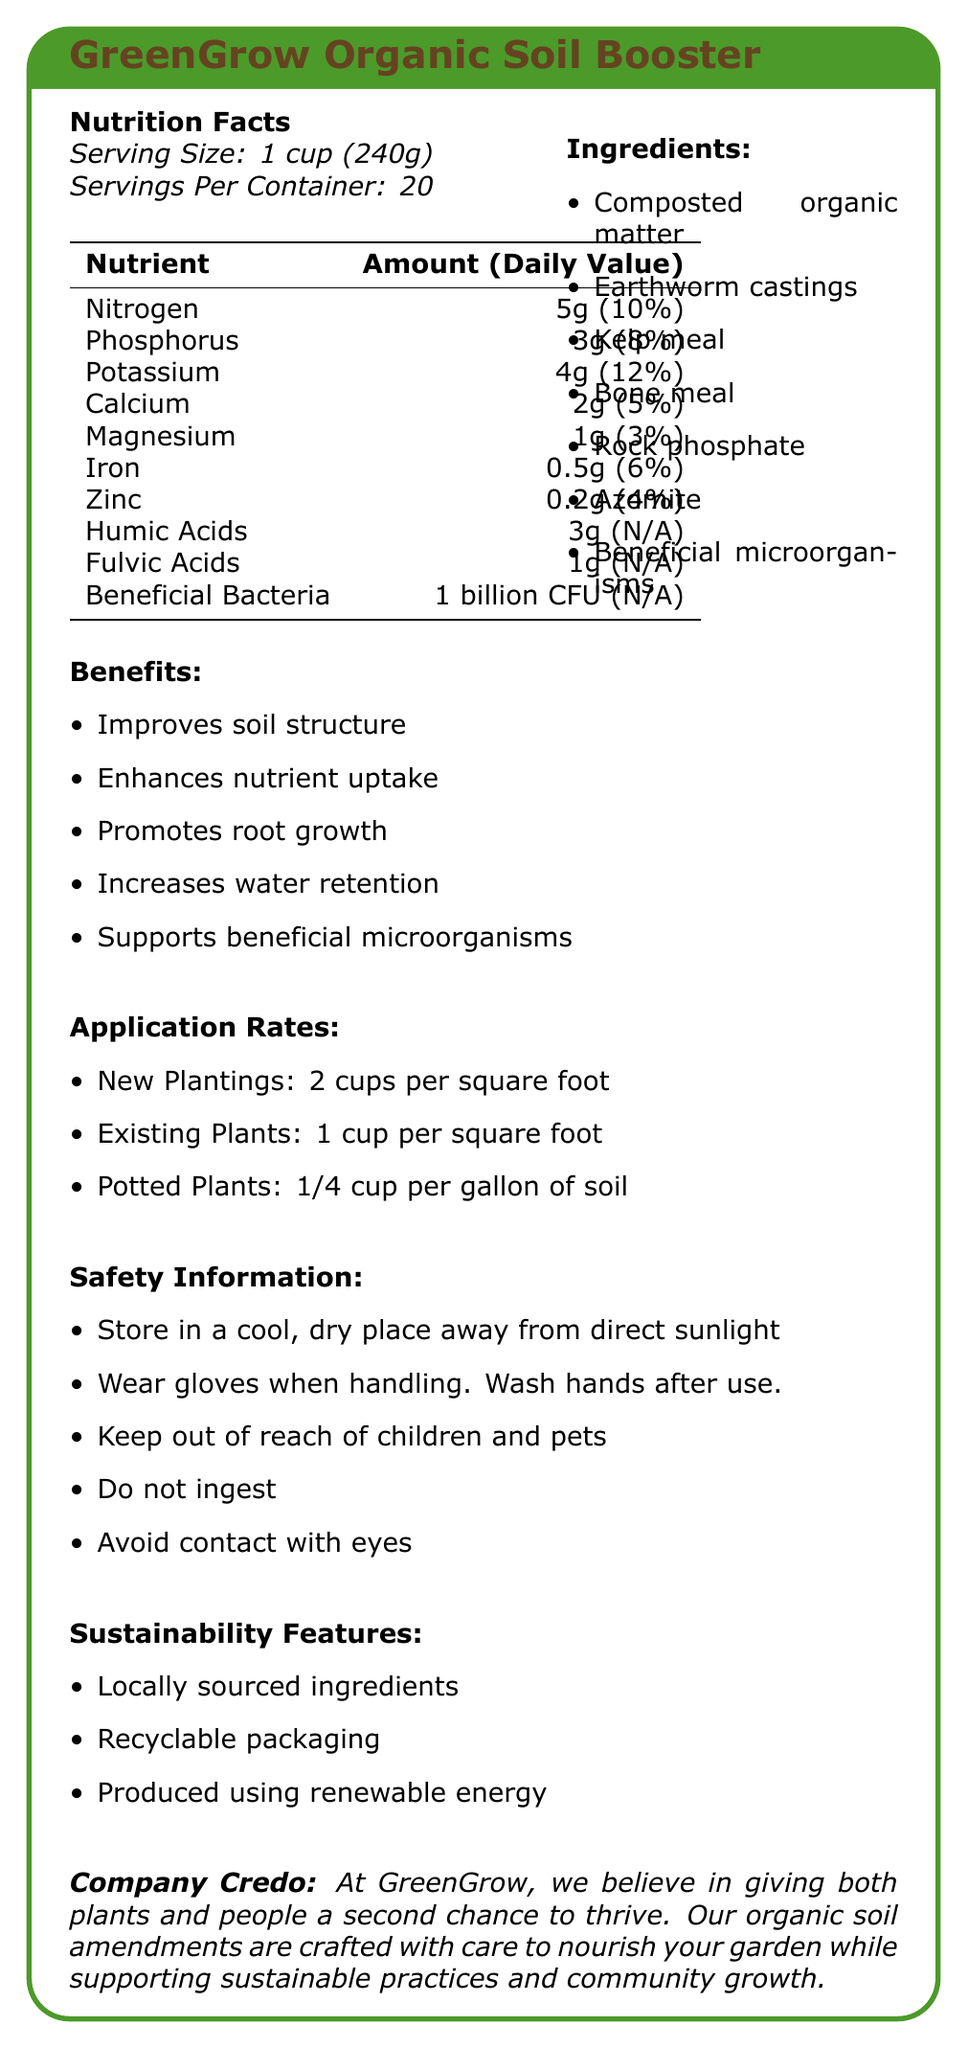what is the serving size of GreenGrow Organic Soil Booster? The serving size is listed as 1 cup (240g) in the Nutrition Facts section of the document.
Answer: 1 cup (240g) How many servings are there per container of GreenGrow Organic Soil Booster? The document states that there are 20 servings per container.
Answer: 20 servings What are the main benefits of using GreenGrow Organic Soil Booster? The Benefits section lists these specific advantages of using the product.
Answer: Improves soil structure, Enhances nutrient uptake, Promotes root growth, Increases water retention, Supports beneficial microorganisms List three key nutrients found in GreenGrow Organic Soil Booster. The Nutrition Facts section lists these nutrients among others with specific amounts.
Answer: Nitrogen, Phosphorus, Potassium Does GreenGrow Organic Soil Booster support beneficial microorganisms? The Ingredients and Benefits sections both mention the inclusion and support of beneficial microorganisms.
Answer: Yes Which nutrient has the highest daily value percentage in GreenGrow Organic Soil Booster? A. Nitrogen B. Phosphorus C. Potassium D. Calcium The Nutrition Facts section shows that Potassium has the highest daily value percentage at 12%.
Answer: C. Potassium What should you do to ensure safety while handling GreenGrow Organic Soil Booster? A. Store in a cool, dry place B. Wear gloves C. Keep out of reach of children and pets D. All of the above The Safety Information section lists all these safety measures.
Answer: D. All of the above Is the packaging of GreenGrow Organic Soil Booster recyclable? The Sustainability Features section states that the packaging is recyclable.
Answer: Yes Does the product contain any kelp meal? The Ingredients section lists kelp meal as one of the components.
Answer: Yes What are GreenGrow Organic Soil Booster's sustainability features? The Sustainability Features section lists these sustainability practices.
Answer: Locally sourced ingredients, Recyclable packaging, Produced using renewable energy Summarize the main idea of the document. The document comprehensively describes the product and its various aspects, highlighting its organic and sustainable nature, as well as its benefits for both plants and community.
Answer: The document provides detailed information about GreenGrow Organic Soil Booster, including its nutrition facts, ingredients, benefits, application rates, safety information, sustainability features, and the company credo. What is the amount of beneficial bacteria in one serving of GreenGrow Organic Soil Booster? The Nutrition Facts section mentions that each serving contains 1 billion CFU of beneficial bacteria.
Answer: 1 billion CFU Can GreenGrow Organic Soil Booster improve soil structure? One of the stated benefits is that it improves soil structure.
Answer: Yes How much GreenGrow Organic Soil Booster should be used for new plantings per square foot? The Application Rates section directs to use 2 cups per square foot for new plantings.
Answer: 2 cups per square foot Do we know the specific sources of the composted organic matter? The document does not specify the sources of the composted organic matter.
Answer: Cannot be determined What is the company's credo mentioned in the document? The Company Credo section contains this statement.
Answer: The company believes in giving both plants and people a second chance to thrive, and their products are crafted to nourish gardens while supporting sustainable practices and community growth. 